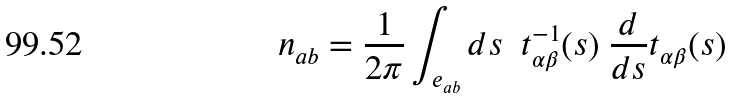<formula> <loc_0><loc_0><loc_500><loc_500>n _ { a b } = \frac { 1 } { 2 \pi } \int _ { e _ { a b } } d s \ \ t ^ { - 1 } _ { \alpha \beta } ( s ) \ \frac { d } { d s } t _ { \alpha \beta } ( s )</formula> 